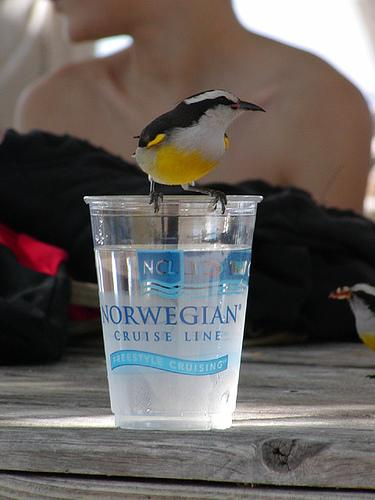What type of vehicle is this cup from?

Choices:
A) ship
B) bus
C) plane
D) train ship 